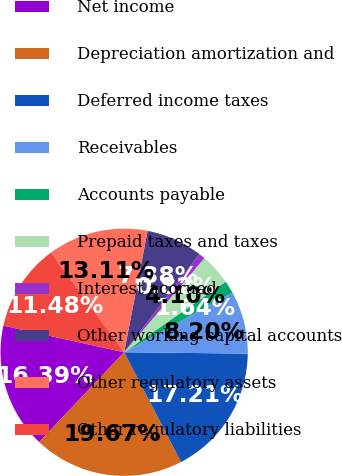<chart> <loc_0><loc_0><loc_500><loc_500><pie_chart><fcel>Net income<fcel>Depreciation amortization and<fcel>Deferred income taxes<fcel>Receivables<fcel>Accounts payable<fcel>Prepaid taxes and taxes<fcel>Interest accrued<fcel>Other working capital accounts<fcel>Other regulatory assets<fcel>Other regulatory liabilities<nl><fcel>16.39%<fcel>19.67%<fcel>17.21%<fcel>8.2%<fcel>1.64%<fcel>4.1%<fcel>0.82%<fcel>7.38%<fcel>13.11%<fcel>11.48%<nl></chart> 